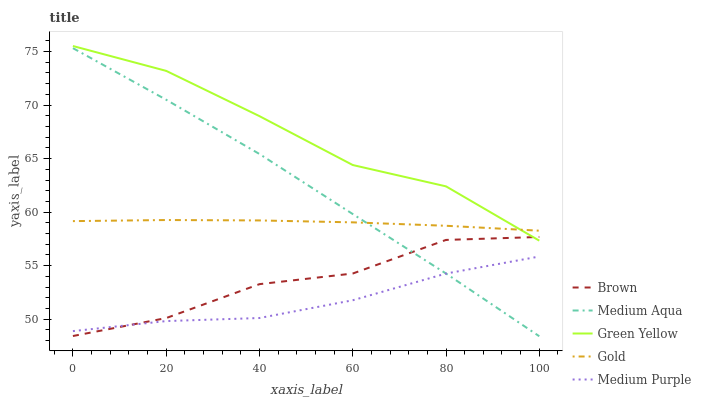Does Brown have the minimum area under the curve?
Answer yes or no. No. Does Brown have the maximum area under the curve?
Answer yes or no. No. Is Green Yellow the smoothest?
Answer yes or no. No. Is Green Yellow the roughest?
Answer yes or no. No. Does Brown have the lowest value?
Answer yes or no. No. Does Brown have the highest value?
Answer yes or no. No. Is Brown less than Gold?
Answer yes or no. Yes. Is Green Yellow greater than Medium Purple?
Answer yes or no. Yes. Does Brown intersect Gold?
Answer yes or no. No. 